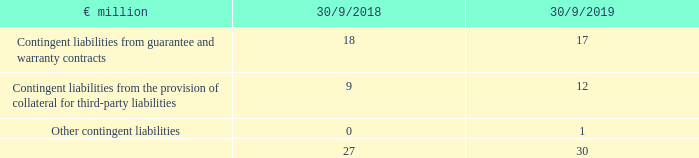45. Contingent liabilities
Contingent liabilities from guarantee and warranty contracts are primarily rent guarantees with terms of up to 10 years if utilisation is not considered entirely unlikely.
What are Contingent liabilities from guarantee and warranty contracts? Primarily rent guarantees with terms of up to 10 years if utilisation is not considered entirely unlikely. What are the Contingent liabilities in FY2019?
Answer scale should be: million. 30. What are the components making up the Contingent liabilities in the table? Contingent liabilities from guarantee and warranty contracts, contingent liabilities from the provision of collateral for third-party liabilities, other contingent liabilities. In which year were contingent liabilities larger? 30>27
Answer: 2019. What was the change in contingent liabilities in FY2019 from FY2018?
Answer scale should be: million. 30-27
Answer: 3. What was the percentage change in contingent liabilities in FY2019 from FY2018?
Answer scale should be: percent. (30-27)/27
Answer: 11.11. 